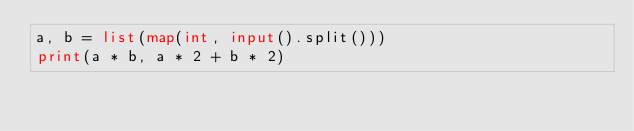<code> <loc_0><loc_0><loc_500><loc_500><_Python_>a, b = list(map(int, input().split()))
print(a * b, a * 2 + b * 2)</code> 